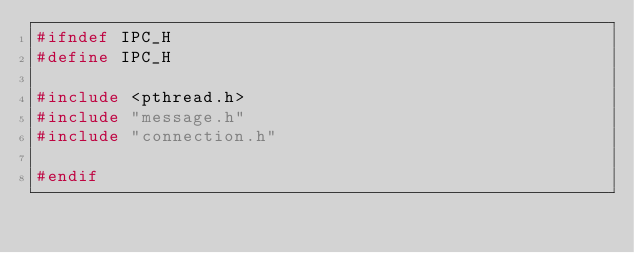Convert code to text. <code><loc_0><loc_0><loc_500><loc_500><_C_>#ifndef IPC_H
#define IPC_H

#include <pthread.h>
#include "message.h"
#include "connection.h"

#endif
</code> 